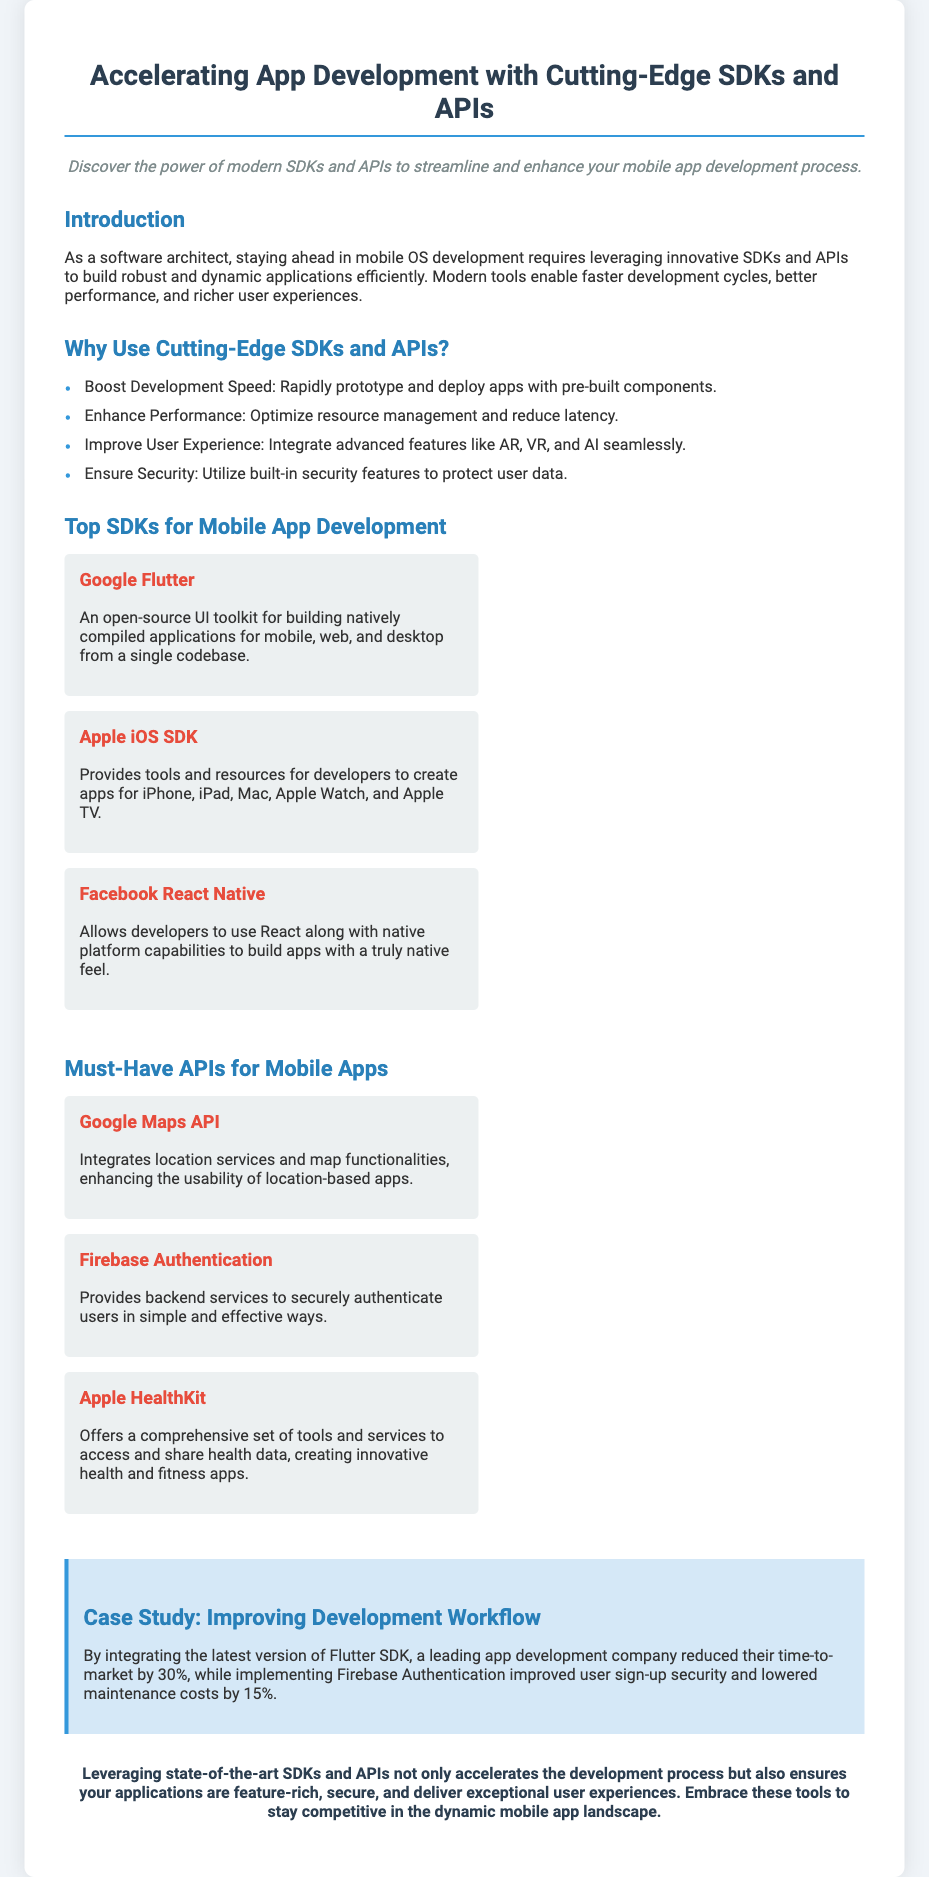What is the title of the flyer? The title of the flyer is prominently displayed at the top of the document, stating the main topic it addresses.
Answer: Accelerating App Development with Cutting-Edge SDKs and APIs What are the advanced features mentioned that can be integrated into apps? The document specifically highlights several modern features that can enhance user experience when developing applications.
Answer: AR, VR, and AI Which SDK is described as an open-source UI toolkit? The document lists specific SDKs and describes their unique features; one is specifically noted as open-source.
Answer: Google Flutter What percentage did a company reduce their time-to-market by using Flutter SDK? The case study provides a specific percentage reflecting the improvement in development speed due to the SDK's implementation.
Answer: 30% What is the main benefit of using Firebase Authentication mentioned in the case study? The document discusses a benefit provided by integrating Firebase Authentication in the context of user authentication security.
Answer: Improved user sign-up security What are the top three APIs listed for mobile apps? A section of the document outlines the must-have APIs, providing three examples with brief descriptions.
Answer: Google Maps API, Firebase Authentication, Apple HealthKit What color is used for the headline? The document has specific formatting details including text color for various headings, notably the main title.
Answer: Dark blue What type of document is this? The structure, content, and design of the document clearly identify its purpose within a specific category.
Answer: Flyer 